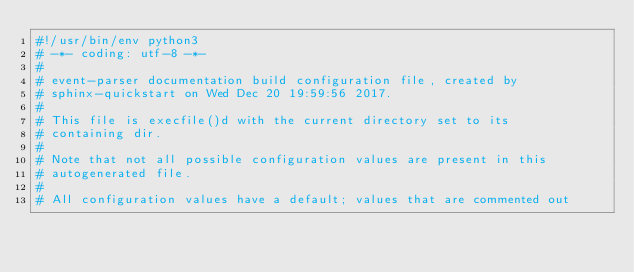Convert code to text. <code><loc_0><loc_0><loc_500><loc_500><_Python_>#!/usr/bin/env python3
# -*- coding: utf-8 -*-
#
# event-parser documentation build configuration file, created by
# sphinx-quickstart on Wed Dec 20 19:59:56 2017.
#
# This file is execfile()d with the current directory set to its
# containing dir.
#
# Note that not all possible configuration values are present in this
# autogenerated file.
#
# All configuration values have a default; values that are commented out</code> 